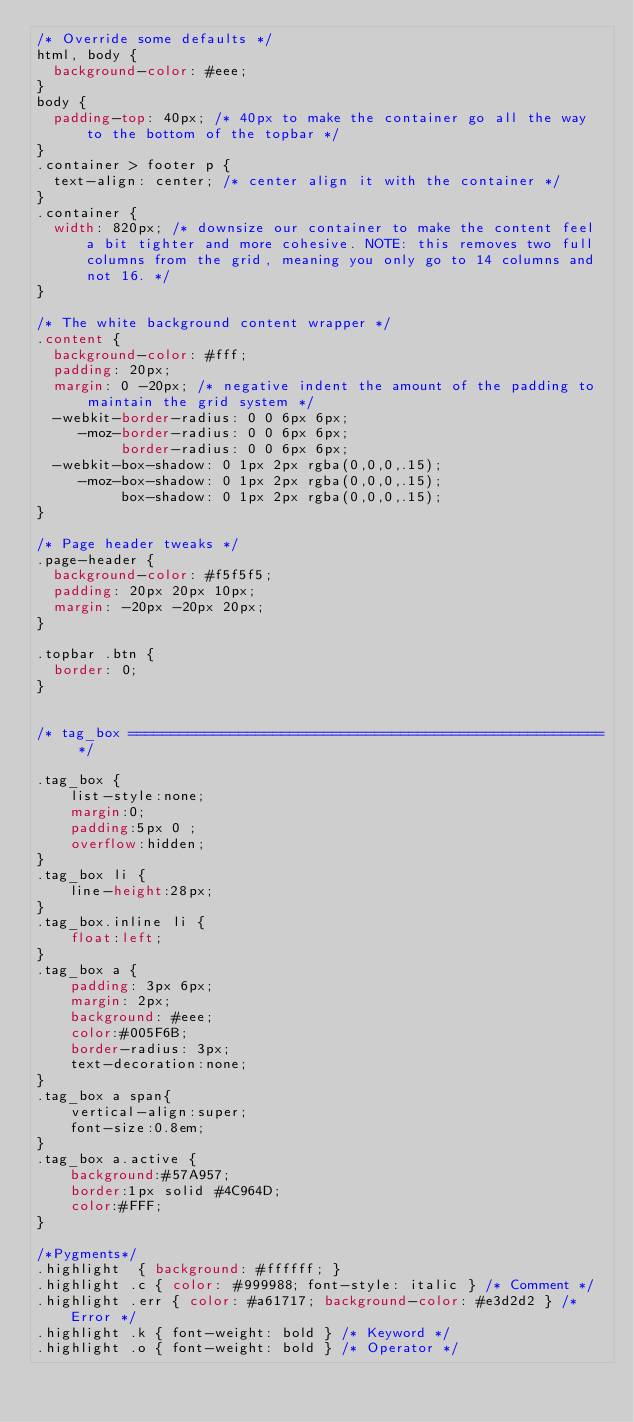Convert code to text. <code><loc_0><loc_0><loc_500><loc_500><_CSS_>/* Override some defaults */
html, body {
  background-color: #eee;
}
body {
  padding-top: 40px; /* 40px to make the container go all the way to the bottom of the topbar */
}
.container > footer p {
  text-align: center; /* center align it with the container */
}
.container {
  width: 820px; /* downsize our container to make the content feel a bit tighter and more cohesive. NOTE: this removes two full columns from the grid, meaning you only go to 14 columns and not 16. */
}

/* The white background content wrapper */
.content {
  background-color: #fff;
  padding: 20px;
  margin: 0 -20px; /* negative indent the amount of the padding to maintain the grid system */
  -webkit-border-radius: 0 0 6px 6px;
     -moz-border-radius: 0 0 6px 6px;
          border-radius: 0 0 6px 6px;
  -webkit-box-shadow: 0 1px 2px rgba(0,0,0,.15);
     -moz-box-shadow: 0 1px 2px rgba(0,0,0,.15);
          box-shadow: 0 1px 2px rgba(0,0,0,.15);
}

/* Page header tweaks */
.page-header {
  background-color: #f5f5f5;
  padding: 20px 20px 10px;
  margin: -20px -20px 20px;
}

.topbar .btn {
  border: 0;
}


/* tag_box ======================================================== */

.tag_box {
	list-style:none;
	margin:0;
	padding:5px 0 ;
	overflow:hidden;
}
.tag_box li {
	line-height:28px;
}
.tag_box.inline li {
	float:left;
}
.tag_box a {
	padding: 3px 6px;
	margin: 2px;
	background: #eee;
	color:#005F6B;
	border-radius: 3px;
	text-decoration:none;
}
.tag_box a span{
	vertical-align:super;
	font-size:0.8em;
}
.tag_box a.active {
	background:#57A957;
	border:1px solid #4C964D;
	color:#FFF;
}

/*Pygments*/
.highlight  { background: #ffffff; }
.highlight .c { color: #999988; font-style: italic } /* Comment */
.highlight .err { color: #a61717; background-color: #e3d2d2 } /* Error */
.highlight .k { font-weight: bold } /* Keyword */
.highlight .o { font-weight: bold } /* Operator */</code> 